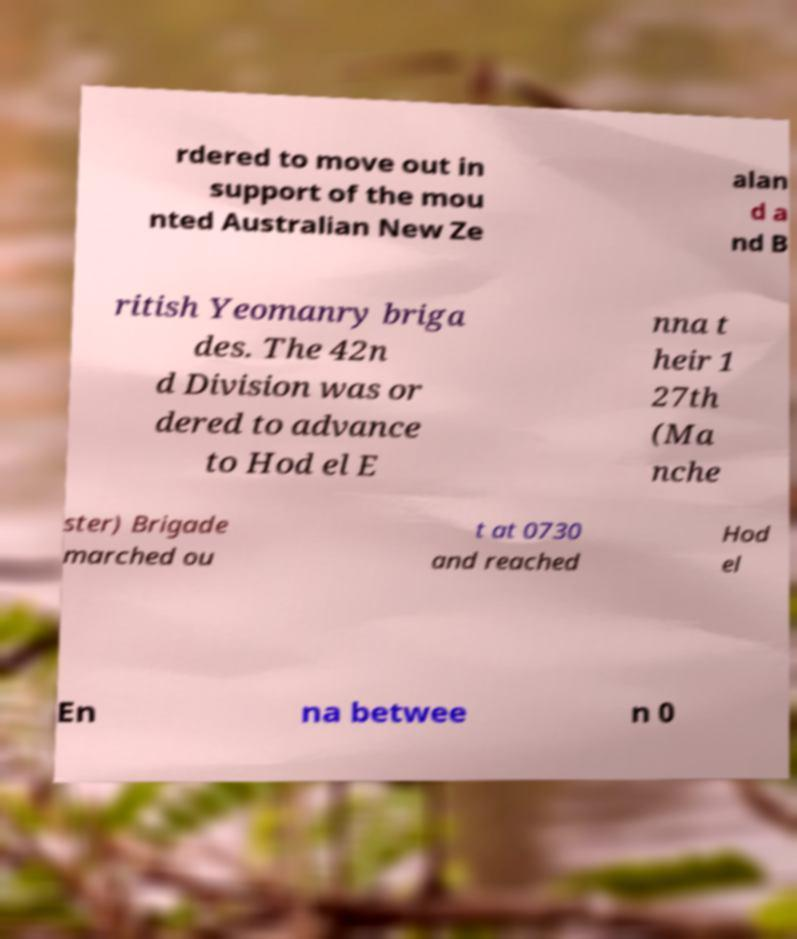There's text embedded in this image that I need extracted. Can you transcribe it verbatim? rdered to move out in support of the mou nted Australian New Ze alan d a nd B ritish Yeomanry briga des. The 42n d Division was or dered to advance to Hod el E nna t heir 1 27th (Ma nche ster) Brigade marched ou t at 0730 and reached Hod el En na betwee n 0 